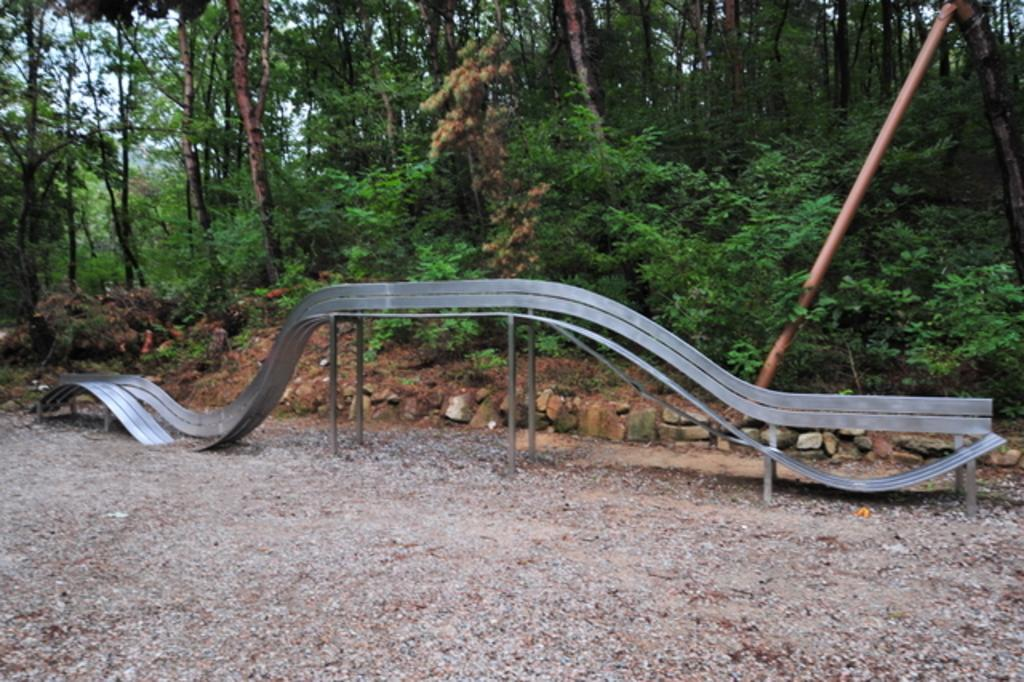What is the main object in the center of the image? There is a metal ramp in the center of the image. Where is the metal ramp located? The metal ramp is on the ground. What type of natural elements can be seen in the image? There are stones visible in the image. What structure is present in the image? There is a pole in the image. What type of vegetation is visible in the image? There is a group of trees in the image. What is visible in the background of the image? The sky is visible in the image. How many kittens are playing with straw on the metal ramp in the image? There are no kittens or straw present in the image; it only features a metal ramp, stones, a pole, trees, and the sky. 